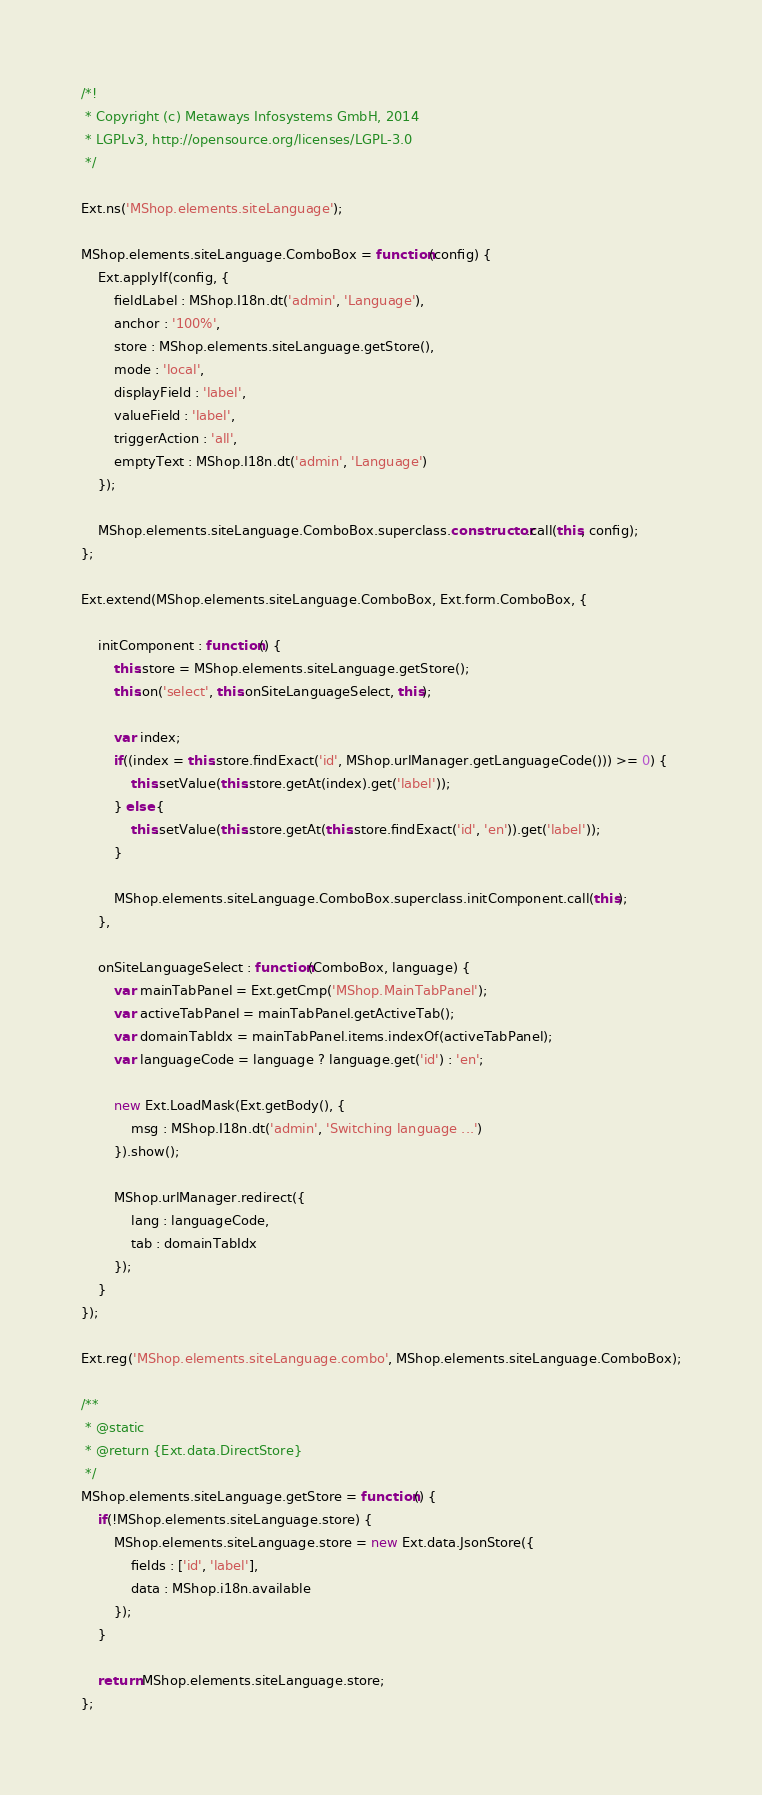<code> <loc_0><loc_0><loc_500><loc_500><_JavaScript_>/*!
 * Copyright (c) Metaways Infosystems GmbH, 2014
 * LGPLv3, http://opensource.org/licenses/LGPL-3.0
 */

Ext.ns('MShop.elements.siteLanguage');

MShop.elements.siteLanguage.ComboBox = function(config) {
    Ext.applyIf(config, {
        fieldLabel : MShop.I18n.dt('admin', 'Language'),
        anchor : '100%',
        store : MShop.elements.siteLanguage.getStore(),
        mode : 'local',
        displayField : 'label',
        valueField : 'label',
        triggerAction : 'all',
        emptyText : MShop.I18n.dt('admin', 'Language')
    });

    MShop.elements.siteLanguage.ComboBox.superclass.constructor.call(this, config);
};

Ext.extend(MShop.elements.siteLanguage.ComboBox, Ext.form.ComboBox, {

    initComponent : function() {
        this.store = MShop.elements.siteLanguage.getStore();
        this.on('select', this.onSiteLanguageSelect, this);

        var index;
        if((index = this.store.findExact('id', MShop.urlManager.getLanguageCode())) >= 0) {
            this.setValue(this.store.getAt(index).get('label'));
        } else {
            this.setValue(this.store.getAt(this.store.findExact('id', 'en')).get('label'));
        }

        MShop.elements.siteLanguage.ComboBox.superclass.initComponent.call(this);
    },

    onSiteLanguageSelect : function(ComboBox, language) {
        var mainTabPanel = Ext.getCmp('MShop.MainTabPanel');
        var activeTabPanel = mainTabPanel.getActiveTab();
        var domainTabIdx = mainTabPanel.items.indexOf(activeTabPanel);
        var languageCode = language ? language.get('id') : 'en';

        new Ext.LoadMask(Ext.getBody(), {
            msg : MShop.I18n.dt('admin', 'Switching language ...')
        }).show();

        MShop.urlManager.redirect({
            lang : languageCode,
            tab : domainTabIdx
        });
    }
});

Ext.reg('MShop.elements.siteLanguage.combo', MShop.elements.siteLanguage.ComboBox);

/**
 * @static
 * @return {Ext.data.DirectStore}
 */
MShop.elements.siteLanguage.getStore = function() {
    if(!MShop.elements.siteLanguage.store) {
        MShop.elements.siteLanguage.store = new Ext.data.JsonStore({
            fields : ['id', 'label'],
            data : MShop.i18n.available
        });
    }

    return MShop.elements.siteLanguage.store;
};
</code> 